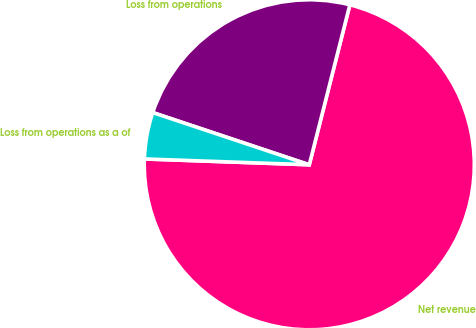<chart> <loc_0><loc_0><loc_500><loc_500><pie_chart><fcel>Net revenue<fcel>Loss from operations<fcel>Loss from operations as a of<nl><fcel>71.61%<fcel>23.83%<fcel>4.56%<nl></chart> 